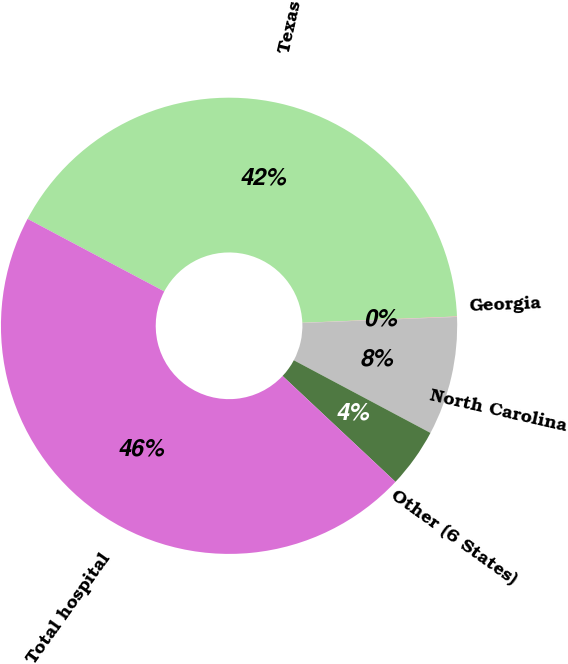Convert chart to OTSL. <chart><loc_0><loc_0><loc_500><loc_500><pie_chart><fcel>Texas<fcel>Georgia<fcel>North Carolina<fcel>Other (6 States)<fcel>Total hospital<nl><fcel>41.58%<fcel>0.03%<fcel>8.4%<fcel>4.21%<fcel>45.77%<nl></chart> 